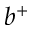Convert formula to latex. <formula><loc_0><loc_0><loc_500><loc_500>b ^ { + }</formula> 